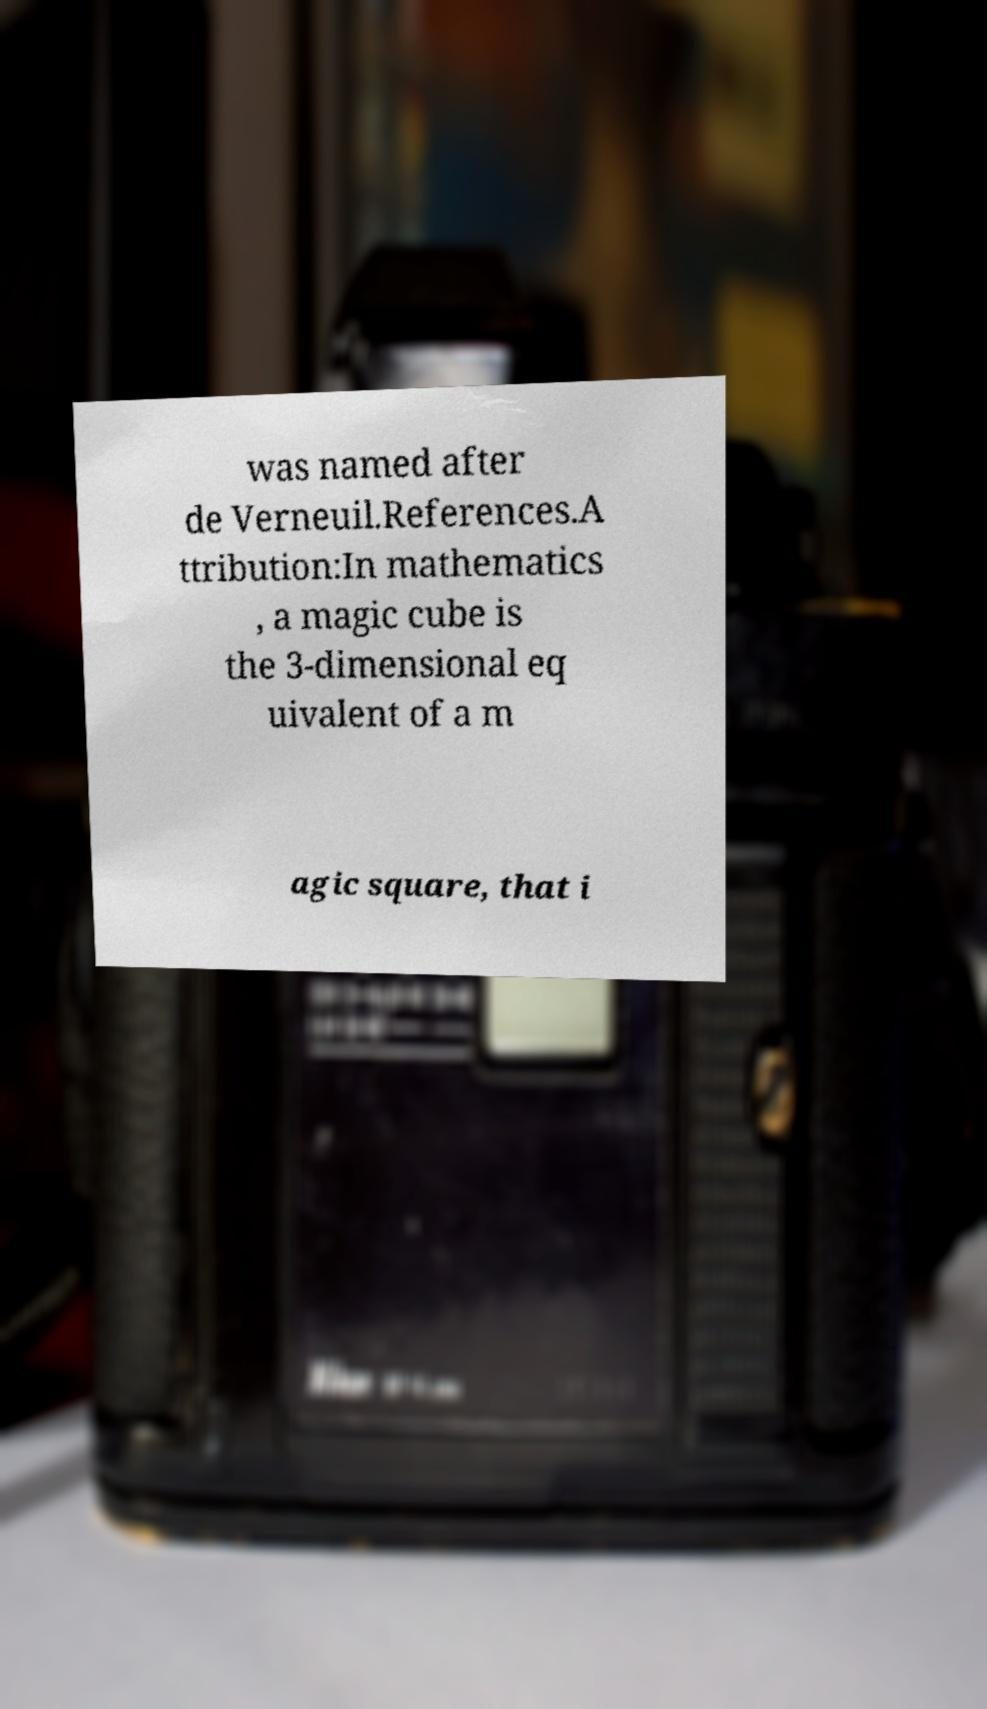Can you accurately transcribe the text from the provided image for me? was named after de Verneuil.References.A ttribution:In mathematics , a magic cube is the 3-dimensional eq uivalent of a m agic square, that i 